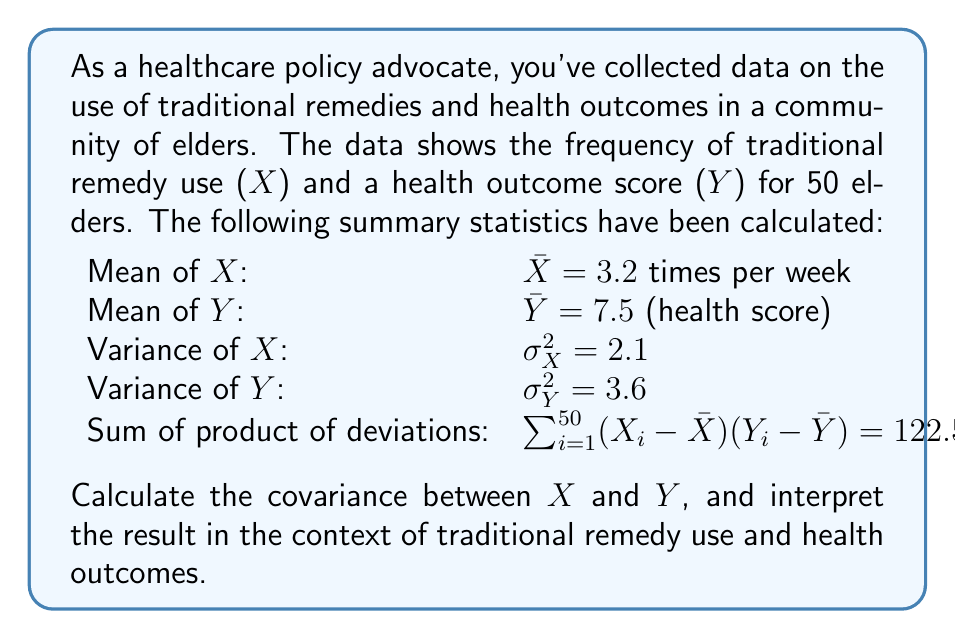Show me your answer to this math problem. To solve this problem, we'll follow these steps:

1) First, recall the formula for covariance:

   $$Cov(X,Y) = \frac{\sum_{i=1}^{n} (X_i - \bar{X})(Y_i - \bar{Y})}{n}$$

   Where n is the number of observations.

2) We're given the sum of product of deviations and the number of observations:

   $\sum_{i=1}^{50} (X_i - \bar{X})(Y_i - \bar{Y}) = 122.5$
   $n = 50$

3) Let's substitute these into the covariance formula:

   $$Cov(X,Y) = \frac{122.5}{50} = 2.45$$

4) Interpretation:
   - The covariance is positive, indicating a positive relationship between the use of traditional remedies and health outcomes.
   - This means that, on average, as the frequency of traditional remedy use increases, the health outcome score tends to increase as well.
   - However, covariance alone doesn't tell us the strength of this relationship, only its direction.

5) To get a better sense of the strength of the relationship, we could calculate the correlation coefficient:

   $$r = \frac{Cov(X,Y)}{\sigma_X \sigma_Y} = \frac{2.45}{\sqrt{2.1} \sqrt{3.6}} \approx 0.79$$

6) This correlation coefficient of 0.79 suggests a strong positive relationship between traditional remedy use and health outcomes in this elder community.
Answer: $Cov(X,Y) = 2.45$, indicating a positive relationship between traditional remedy use and health outcomes. 